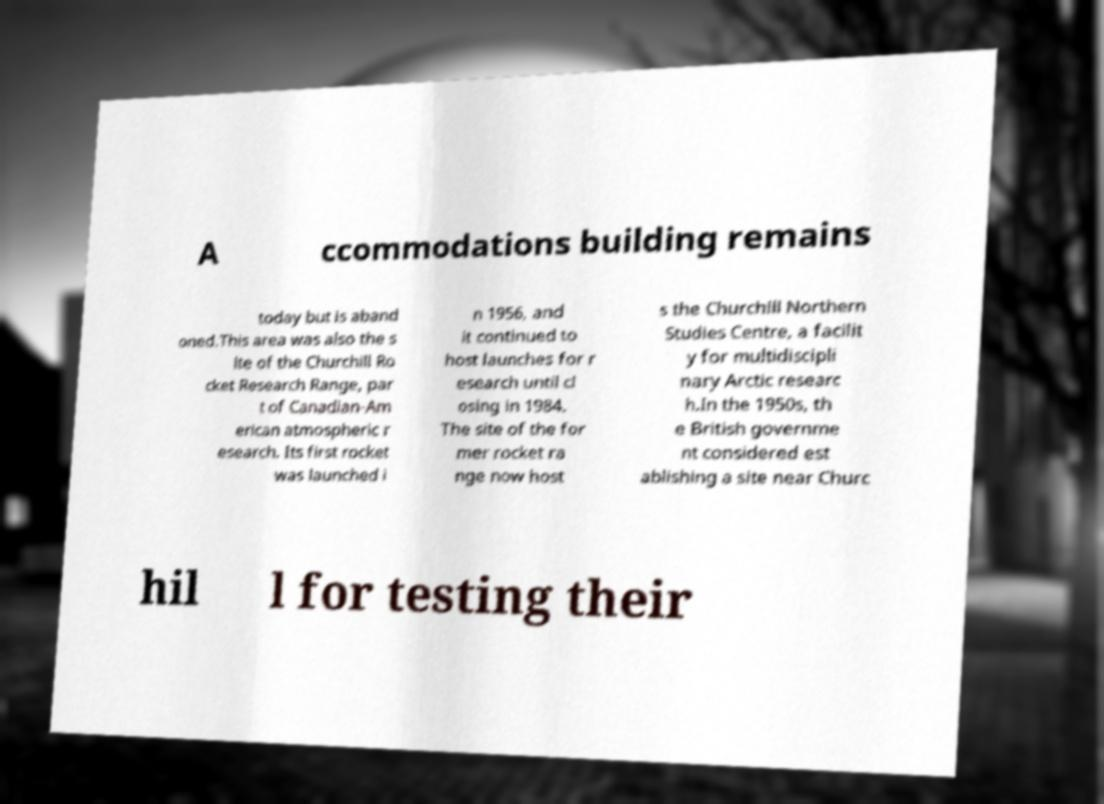Can you accurately transcribe the text from the provided image for me? A ccommodations building remains today but is aband oned.This area was also the s ite of the Churchill Ro cket Research Range, par t of Canadian-Am erican atmospheric r esearch. Its first rocket was launched i n 1956, and it continued to host launches for r esearch until cl osing in 1984. The site of the for mer rocket ra nge now host s the Churchill Northern Studies Centre, a facilit y for multidiscipli nary Arctic researc h.In the 1950s, th e British governme nt considered est ablishing a site near Churc hil l for testing their 